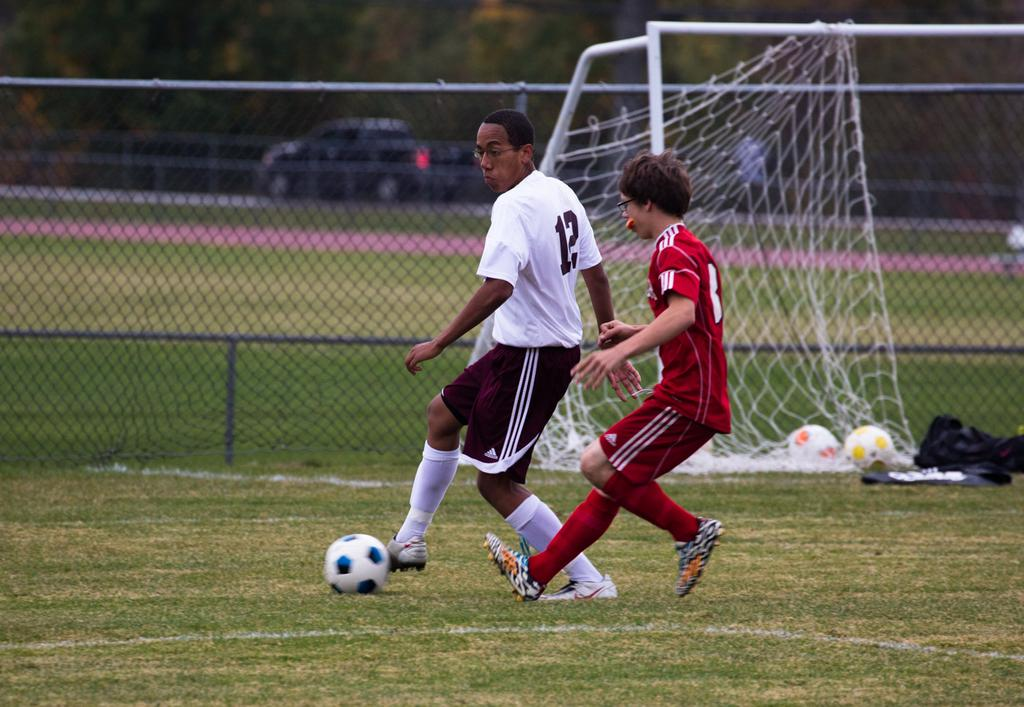<image>
Offer a succinct explanation of the picture presented. Soccer player with maroon shorts that have the Adidas logo. 